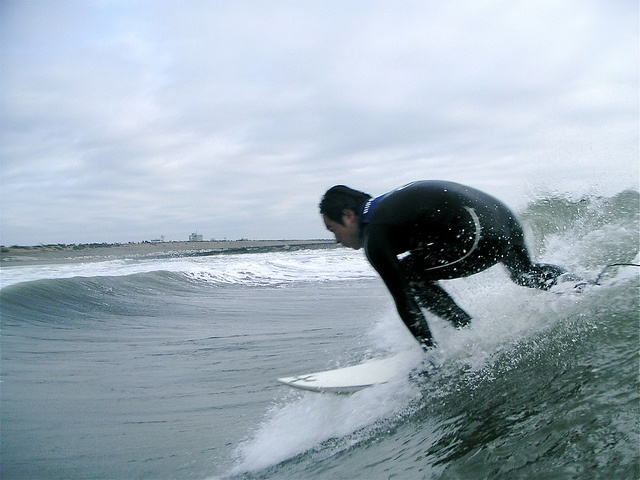Describe the objects in this image and their specific colors. I can see people in darkgray, black, gray, blue, and darkblue tones and surfboard in darkgray and lightgray tones in this image. 